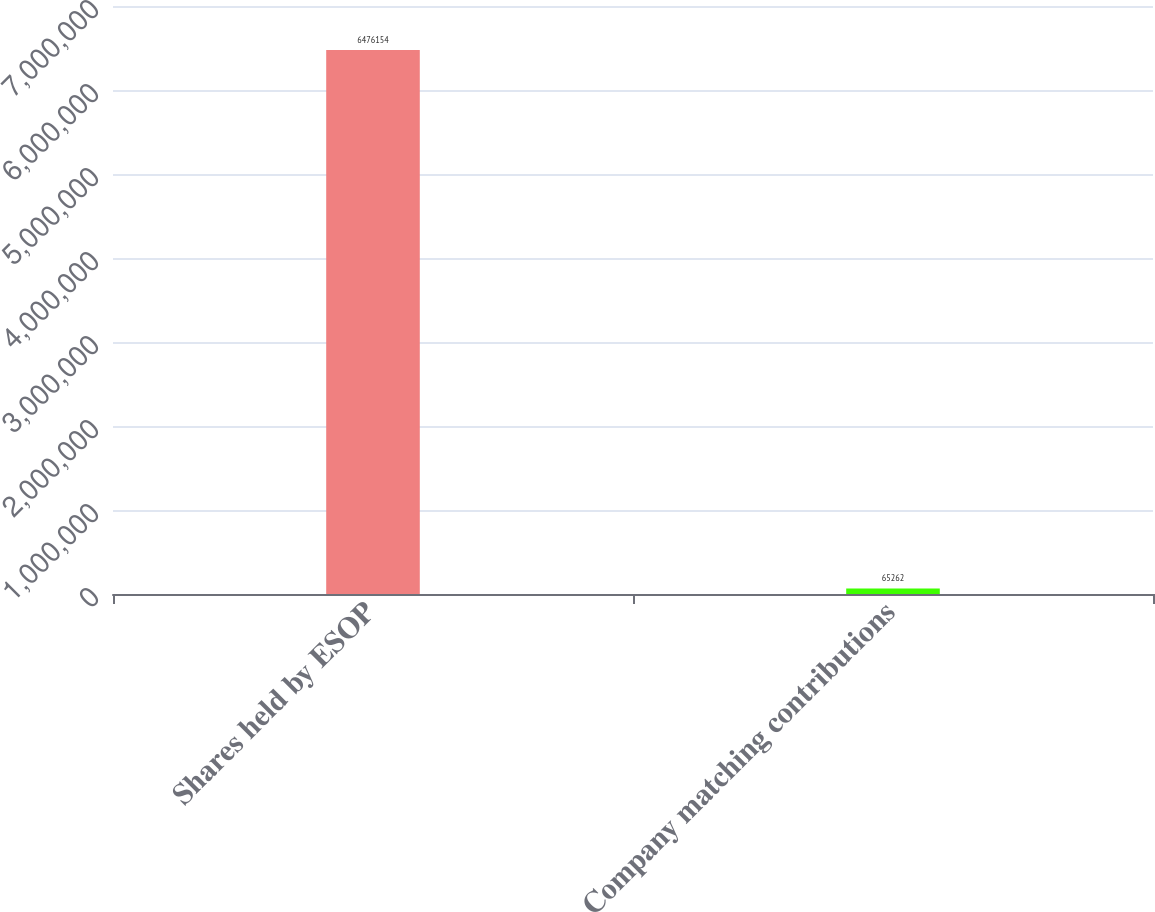Convert chart to OTSL. <chart><loc_0><loc_0><loc_500><loc_500><bar_chart><fcel>Shares held by ESOP<fcel>Company matching contributions<nl><fcel>6.47615e+06<fcel>65262<nl></chart> 